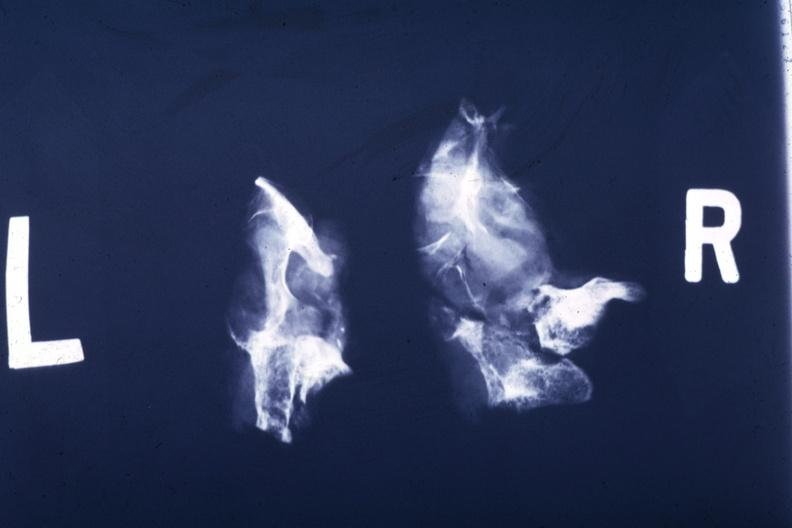does cells show partially destroyed bone and large soft tissue mass?
Answer the question using a single word or phrase. No 